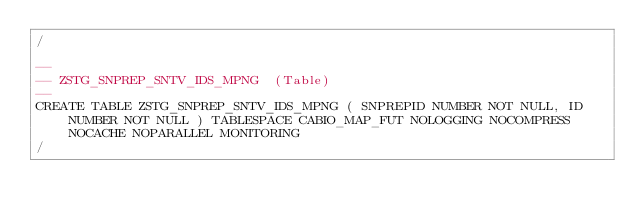Convert code to text. <code><loc_0><loc_0><loc_500><loc_500><_SQL_>/

--
-- ZSTG_SNPREP_SNTV_IDS_MPNG  (Table) 
--
CREATE TABLE ZSTG_SNPREP_SNTV_IDS_MPNG ( SNPREPID NUMBER NOT NULL, ID NUMBER NOT NULL ) TABLESPACE CABIO_MAP_FUT NOLOGGING NOCOMPRESS NOCACHE NOPARALLEL MONITORING
/


</code> 